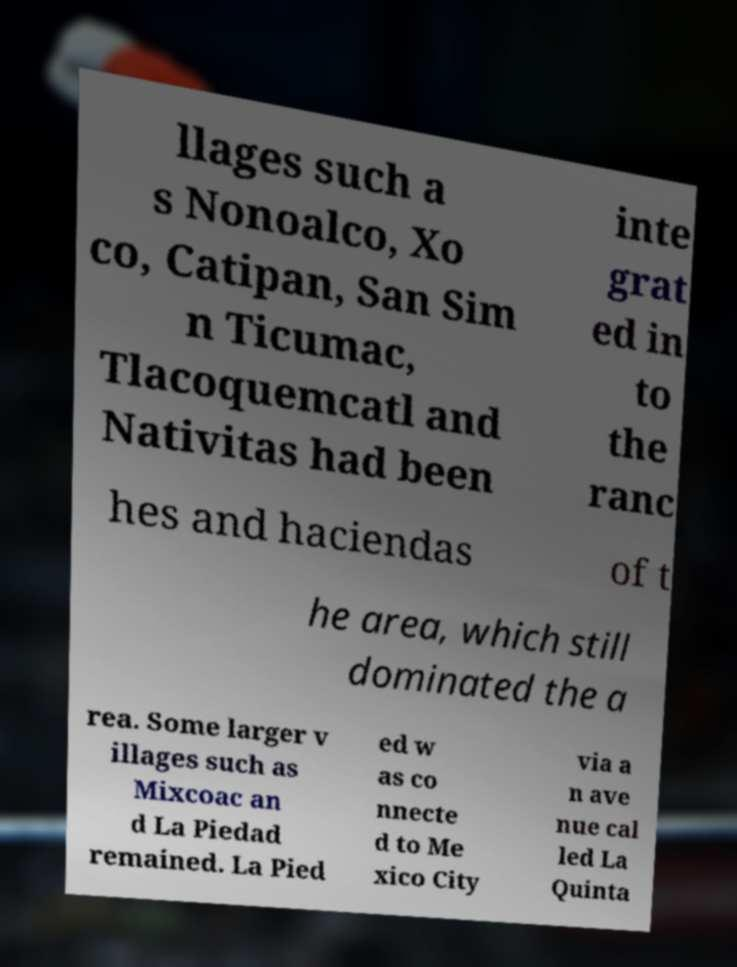Could you extract and type out the text from this image? llages such a s Nonoalco, Xo co, Catipan, San Sim n Ticumac, Tlacoquemcatl and Nativitas had been inte grat ed in to the ranc hes and haciendas of t he area, which still dominated the a rea. Some larger v illages such as Mixcoac an d La Piedad remained. La Pied ed w as co nnecte d to Me xico City via a n ave nue cal led La Quinta 